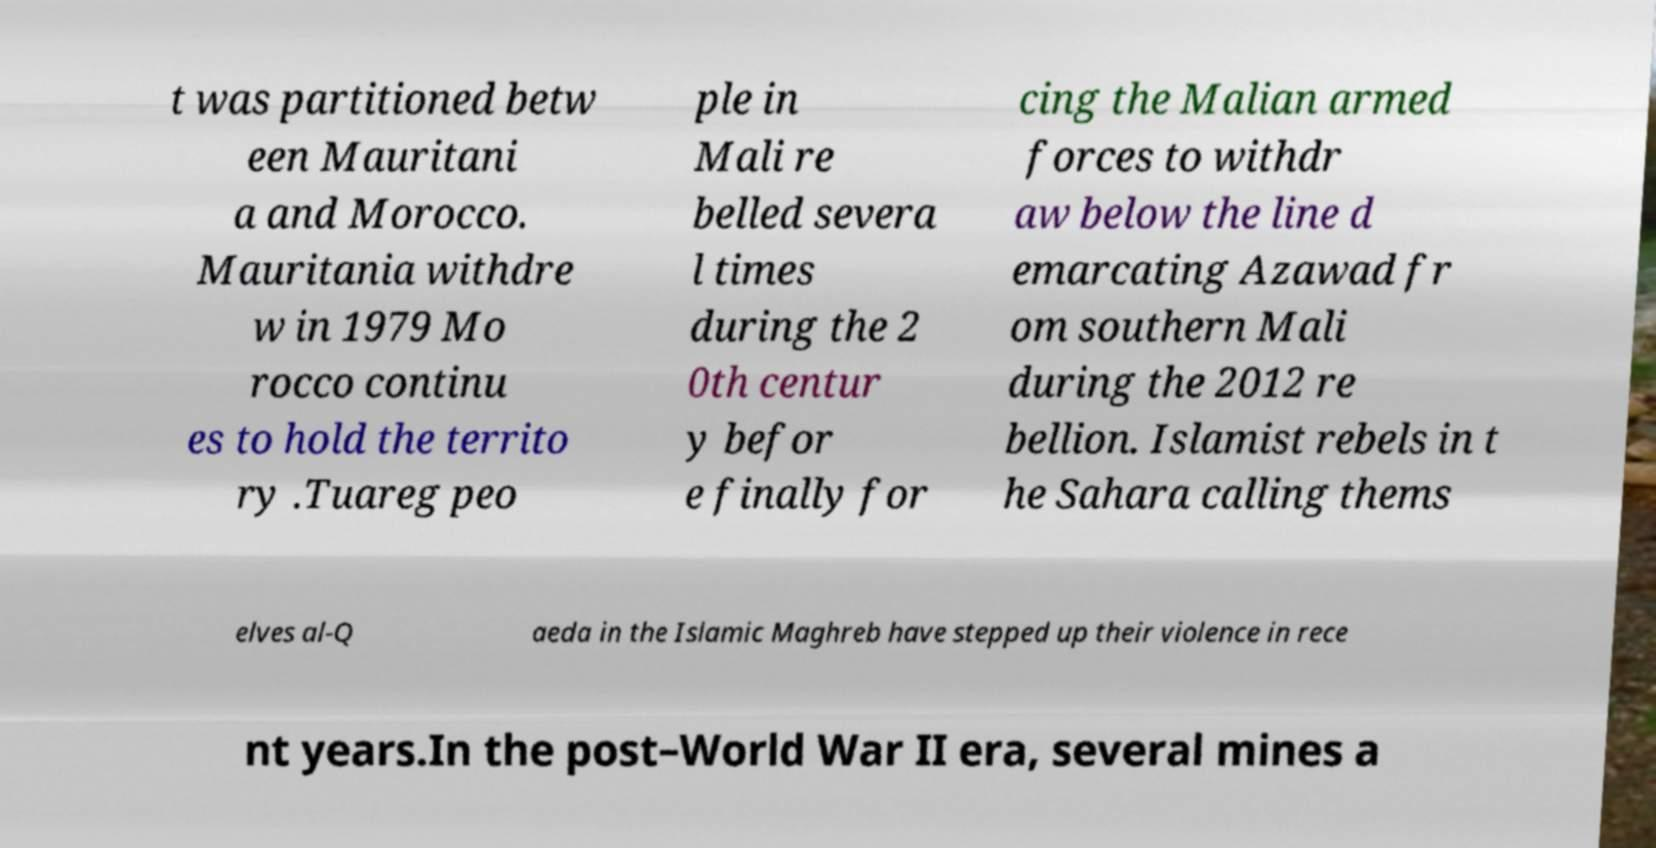For documentation purposes, I need the text within this image transcribed. Could you provide that? t was partitioned betw een Mauritani a and Morocco. Mauritania withdre w in 1979 Mo rocco continu es to hold the territo ry .Tuareg peo ple in Mali re belled severa l times during the 2 0th centur y befor e finally for cing the Malian armed forces to withdr aw below the line d emarcating Azawad fr om southern Mali during the 2012 re bellion. Islamist rebels in t he Sahara calling thems elves al-Q aeda in the Islamic Maghreb have stepped up their violence in rece nt years.In the post–World War II era, several mines a 